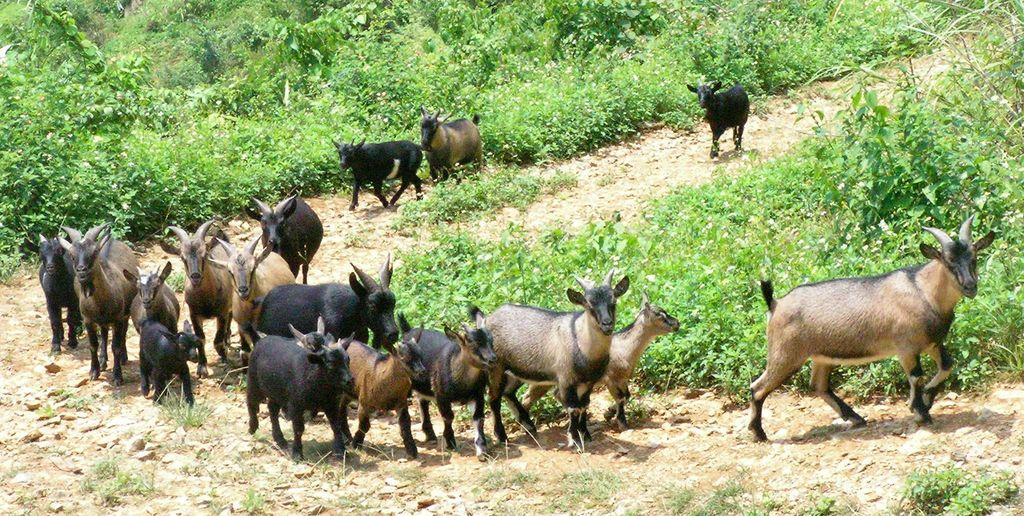What types of living organisms can be seen in the image? Animals and plants can be seen in the image. What type of vegetation is present in the image? Trees are present in the image. What type of hospital can be seen in the image? There is no hospital present in the image; it features animals and plants. How many passengers are visible in the image? There are no passengers present in the image; it features animals and plants. 